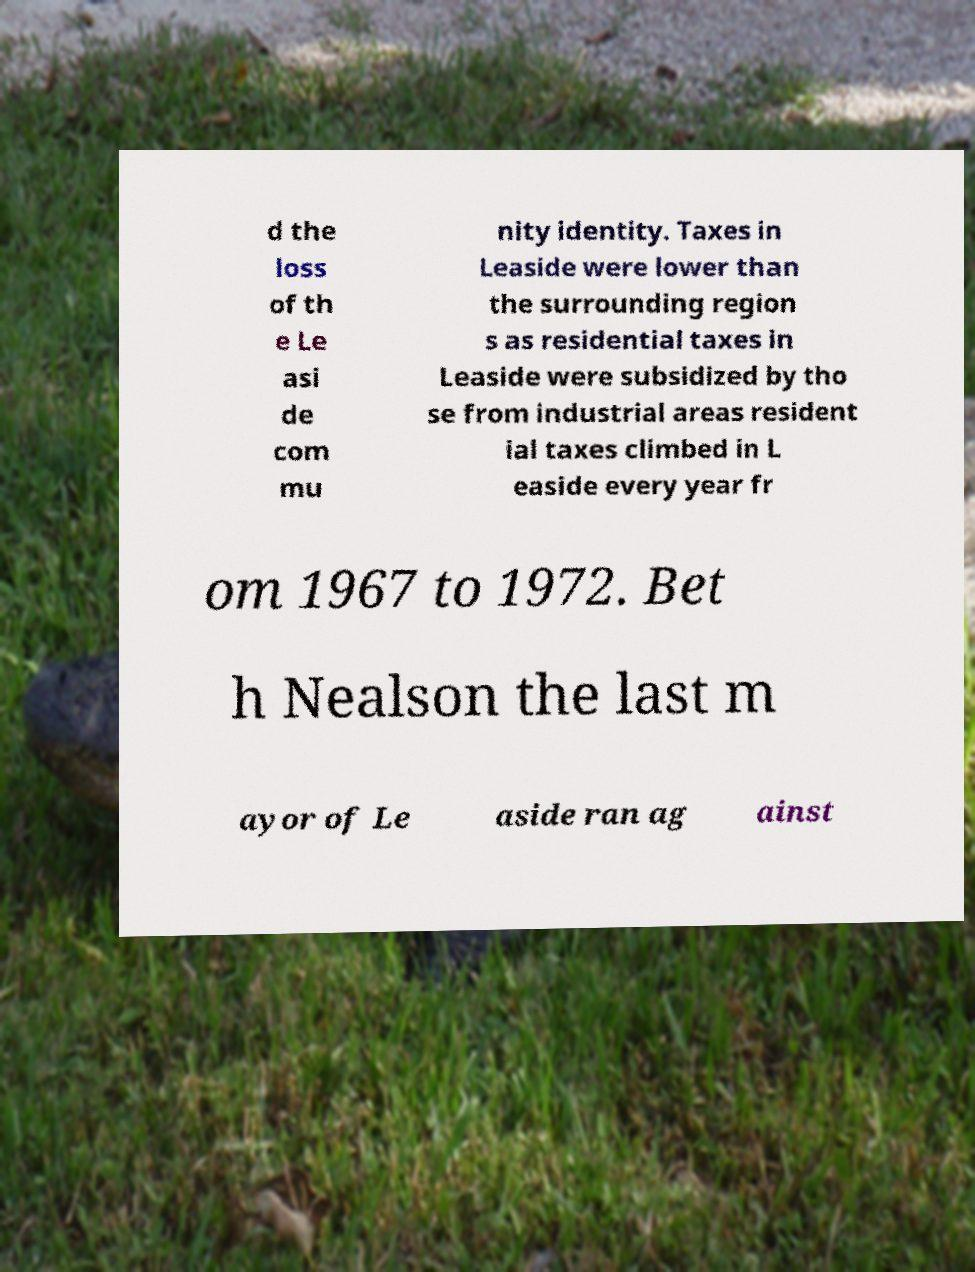Can you accurately transcribe the text from the provided image for me? d the loss of th e Le asi de com mu nity identity. Taxes in Leaside were lower than the surrounding region s as residential taxes in Leaside were subsidized by tho se from industrial areas resident ial taxes climbed in L easide every year fr om 1967 to 1972. Bet h Nealson the last m ayor of Le aside ran ag ainst 